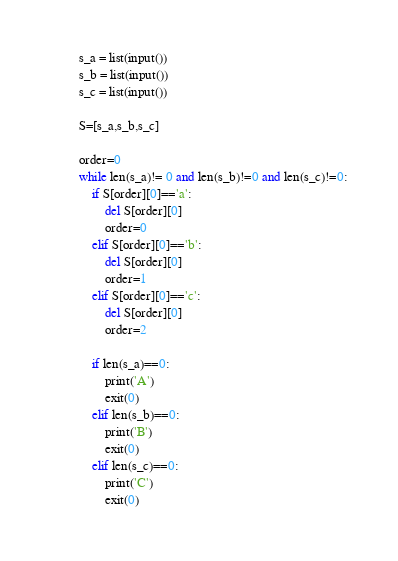<code> <loc_0><loc_0><loc_500><loc_500><_Python_>s_a = list(input())
s_b = list(input())
s_c = list(input())

S=[s_a,s_b,s_c]

order=0
while len(s_a)!= 0 and len(s_b)!=0 and len(s_c)!=0:
    if S[order][0]=='a':
        del S[order][0]
        order=0
    elif S[order][0]=='b':
        del S[order][0]
        order=1
    elif S[order][0]=='c':
        del S[order][0]
        order=2

    if len(s_a)==0:
        print('A')
        exit(0)
    elif len(s_b)==0:
        print('B')
        exit(0)
    elif len(s_c)==0:
        print('C')
        exit(0)</code> 